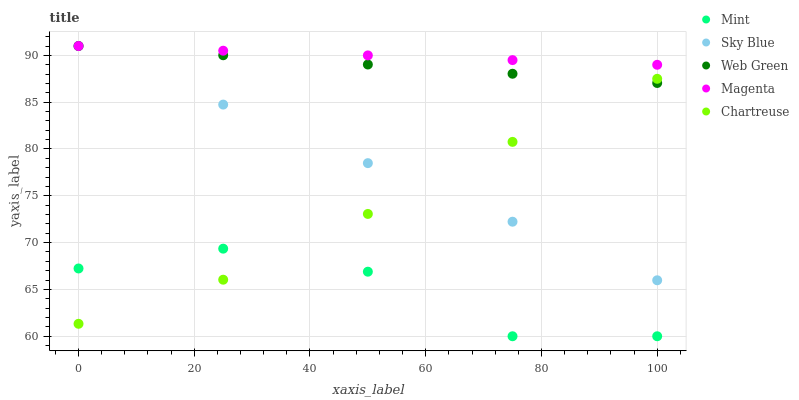Does Mint have the minimum area under the curve?
Answer yes or no. Yes. Does Magenta have the maximum area under the curve?
Answer yes or no. Yes. Does Magenta have the minimum area under the curve?
Answer yes or no. No. Does Mint have the maximum area under the curve?
Answer yes or no. No. Is Sky Blue the smoothest?
Answer yes or no. Yes. Is Mint the roughest?
Answer yes or no. Yes. Is Magenta the smoothest?
Answer yes or no. No. Is Magenta the roughest?
Answer yes or no. No. Does Mint have the lowest value?
Answer yes or no. Yes. Does Magenta have the lowest value?
Answer yes or no. No. Does Web Green have the highest value?
Answer yes or no. Yes. Does Mint have the highest value?
Answer yes or no. No. Is Mint less than Magenta?
Answer yes or no. Yes. Is Sky Blue greater than Mint?
Answer yes or no. Yes. Does Magenta intersect Sky Blue?
Answer yes or no. Yes. Is Magenta less than Sky Blue?
Answer yes or no. No. Is Magenta greater than Sky Blue?
Answer yes or no. No. Does Mint intersect Magenta?
Answer yes or no. No. 